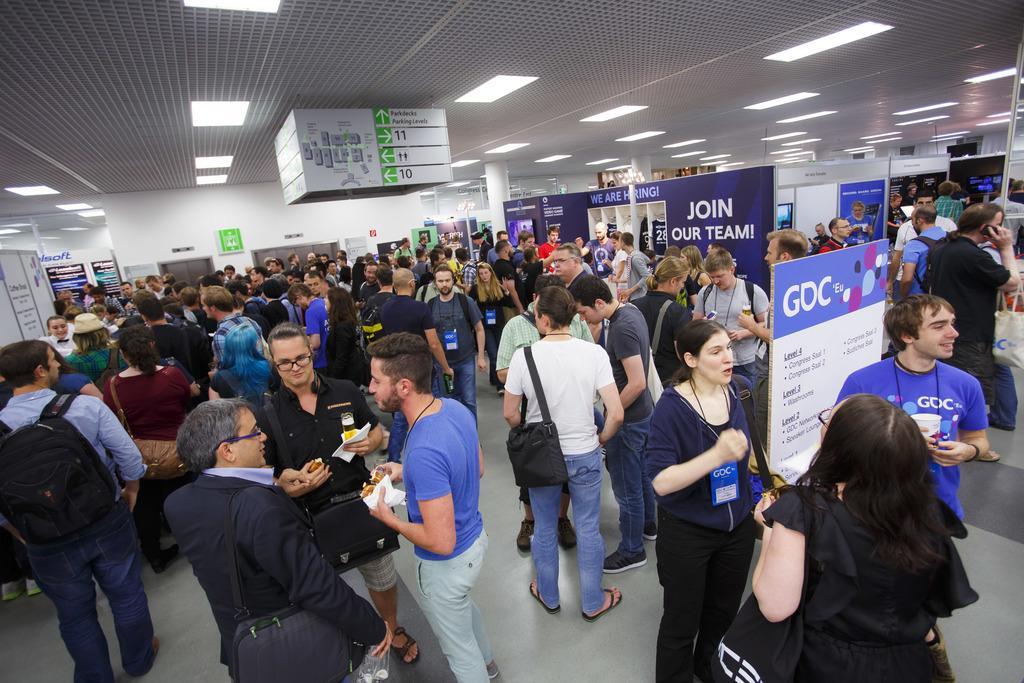Can you describe this image briefly? In this image I can see group of people standing. In front the person is holding the food and I can also see few boards in blue and white color and I can see few lights and the wall is in white color. 